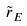Convert formula to latex. <formula><loc_0><loc_0><loc_500><loc_500>\tilde { r } _ { E }</formula> 